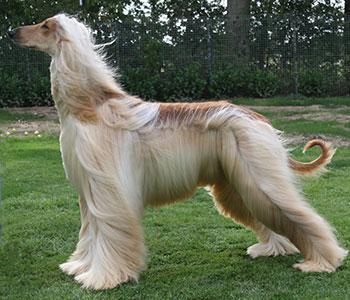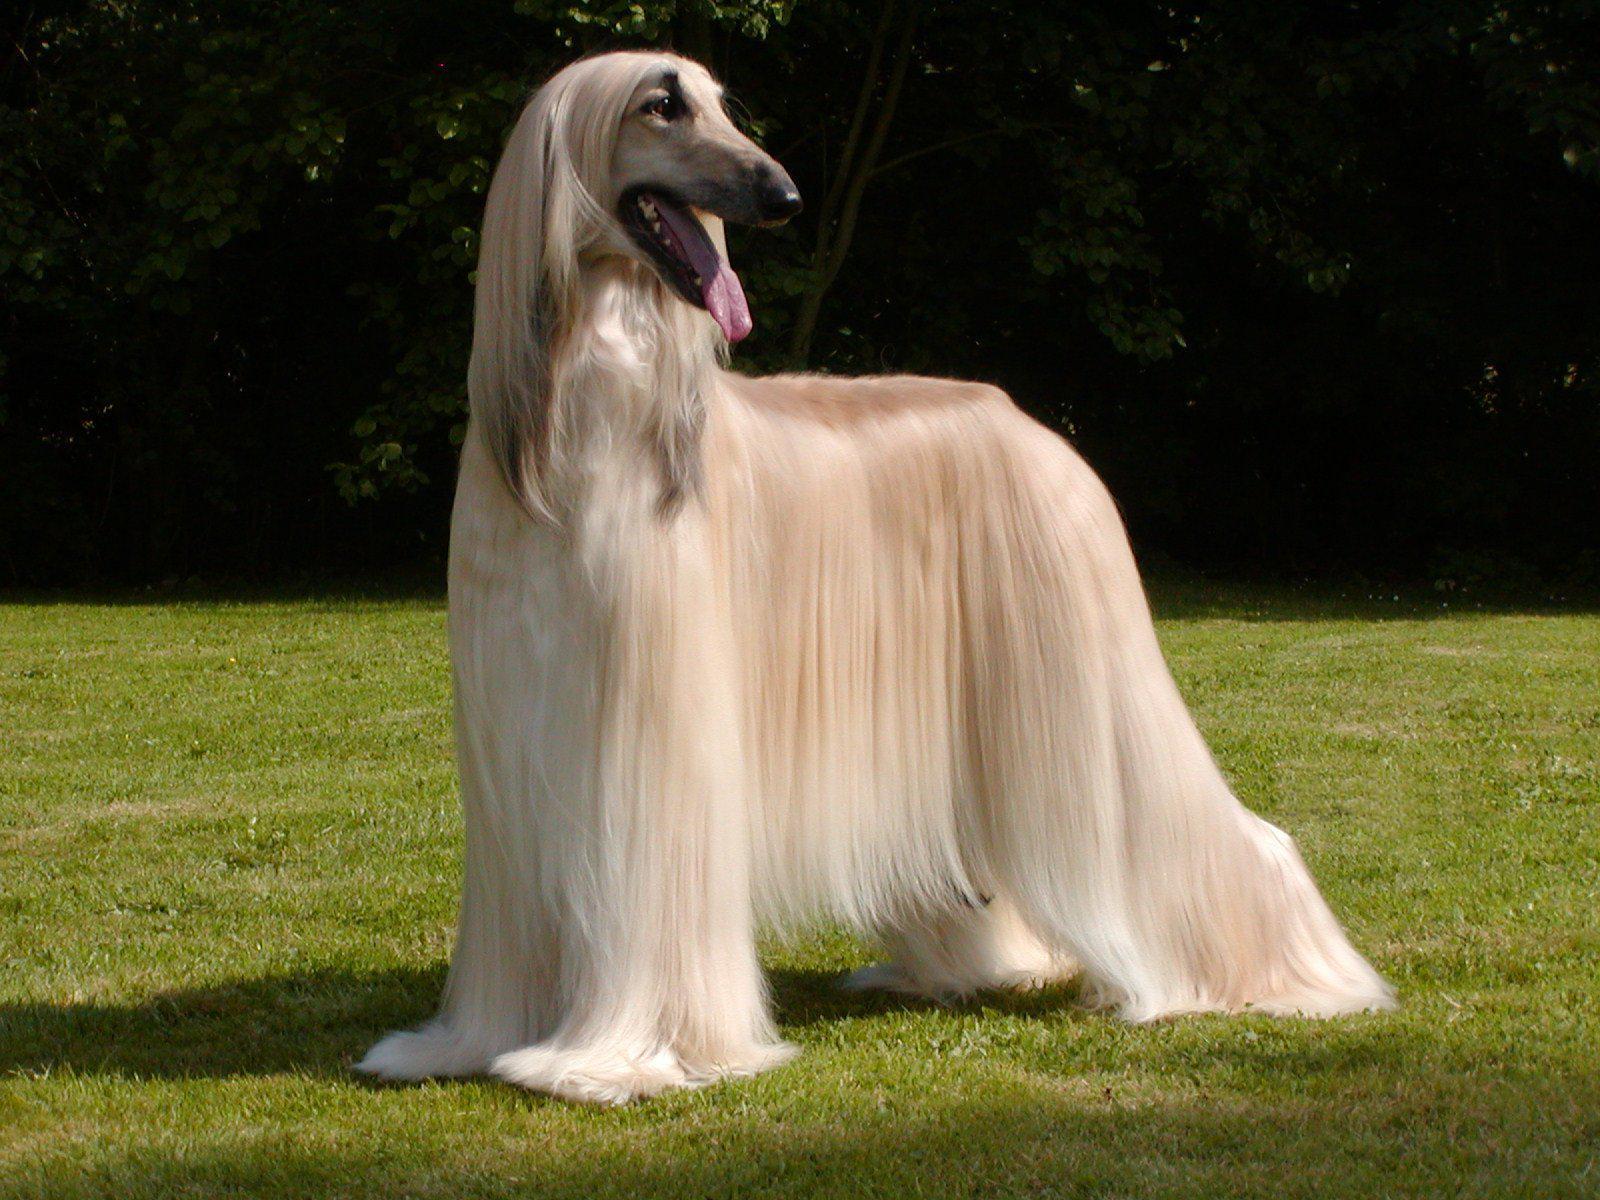The first image is the image on the left, the second image is the image on the right. Given the left and right images, does the statement "Both dogs are standing on a grassy area." hold true? Answer yes or no. Yes. The first image is the image on the left, the second image is the image on the right. Analyze the images presented: Is the assertion "Each image shows one blonde hound with long silky hair standing on a green grassy area." valid? Answer yes or no. Yes. 